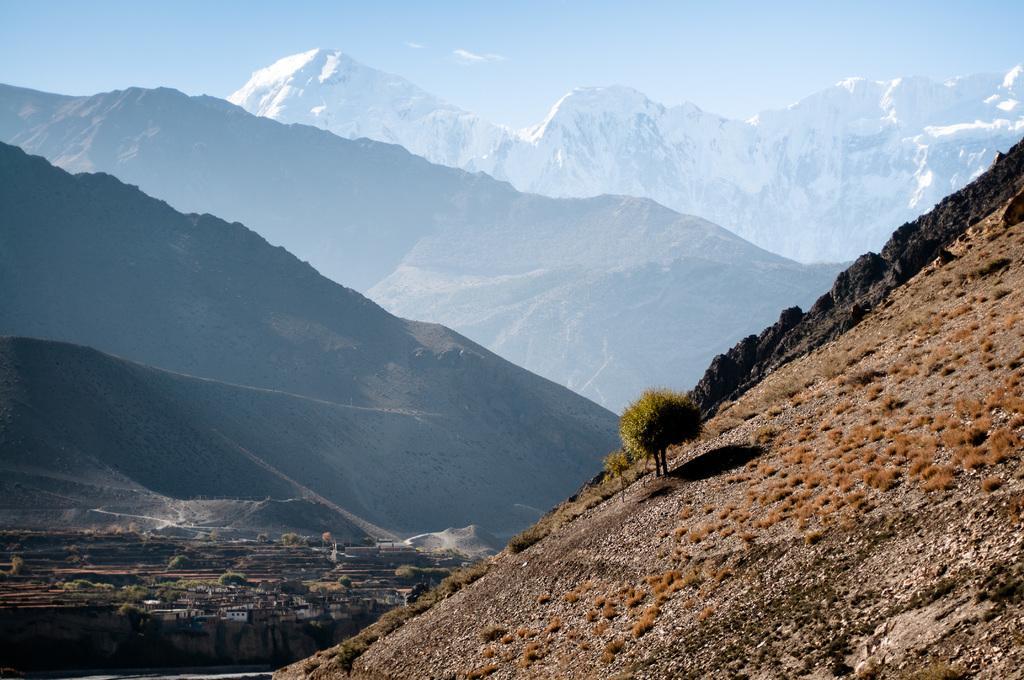How would you summarize this image in a sentence or two? In this image there is the sky truncated towards the top of the image, there are mountains, there are mountains truncated towards the right of the image, there are mountains truncated towards the left of the image, there are trees, there are plants, there is a mountain truncated towards the bottom of the image. 